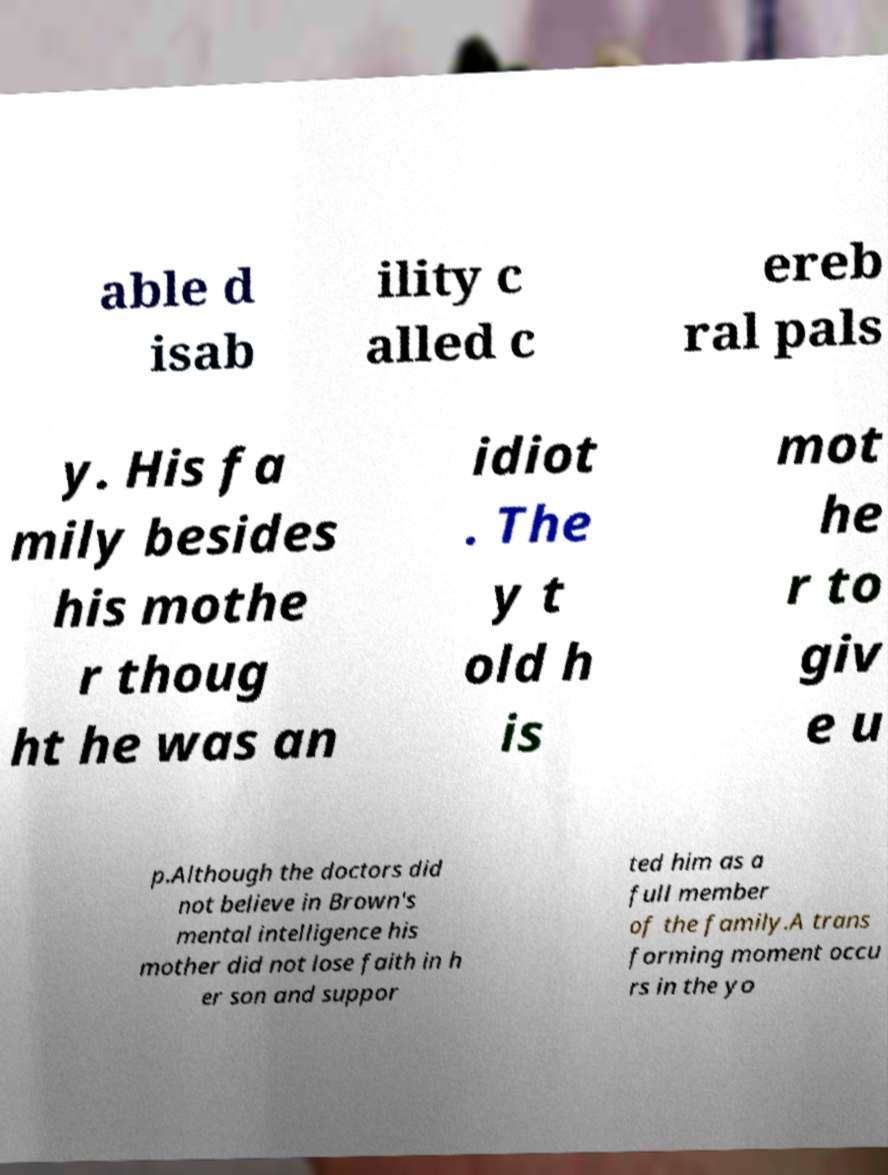Please identify and transcribe the text found in this image. able d isab ility c alled c ereb ral pals y. His fa mily besides his mothe r thoug ht he was an idiot . The y t old h is mot he r to giv e u p.Although the doctors did not believe in Brown's mental intelligence his mother did not lose faith in h er son and suppor ted him as a full member of the family.A trans forming moment occu rs in the yo 